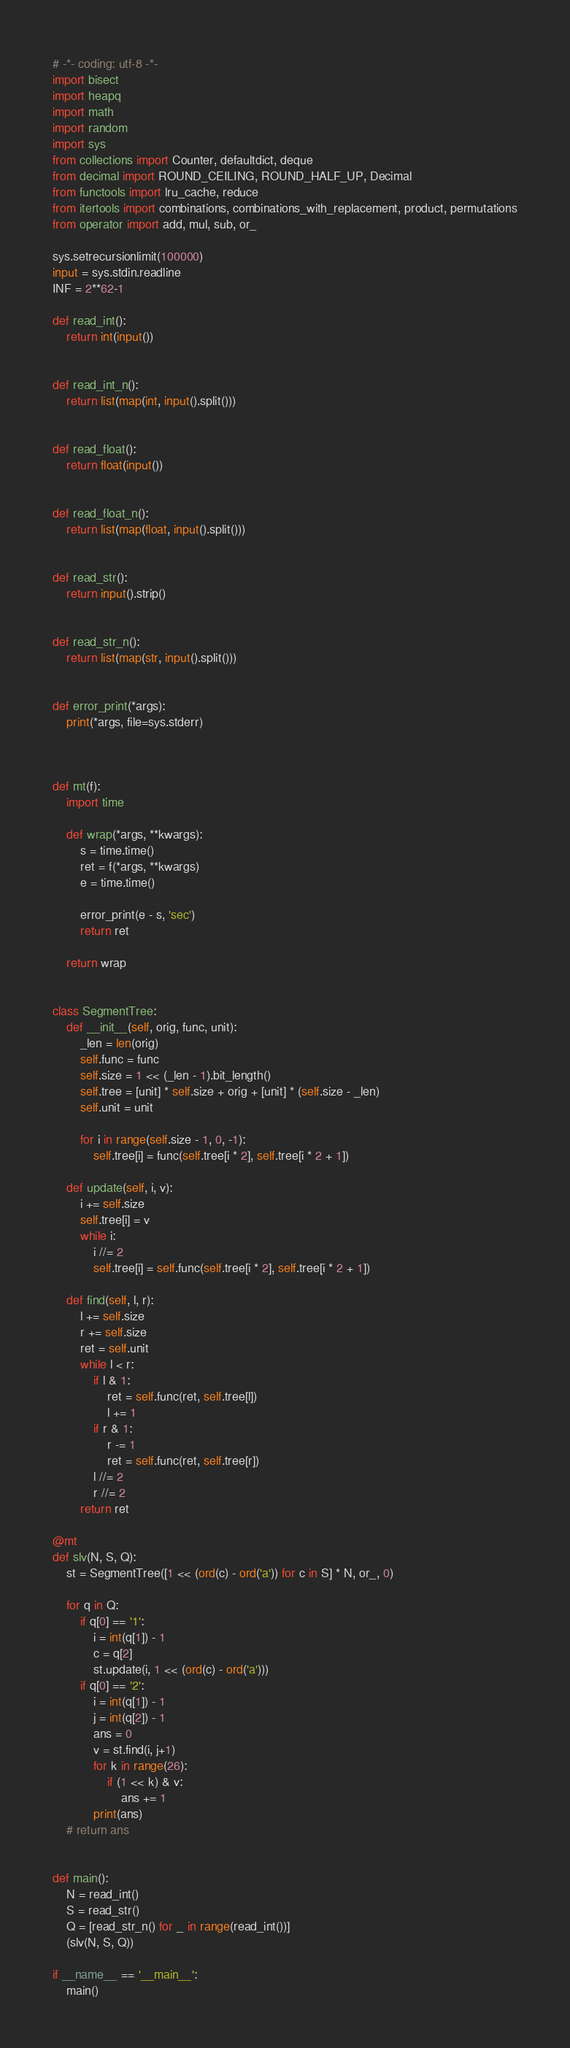<code> <loc_0><loc_0><loc_500><loc_500><_Python_># -*- coding: utf-8 -*-
import bisect
import heapq
import math
import random
import sys
from collections import Counter, defaultdict, deque
from decimal import ROUND_CEILING, ROUND_HALF_UP, Decimal
from functools import lru_cache, reduce
from itertools import combinations, combinations_with_replacement, product, permutations
from operator import add, mul, sub, or_

sys.setrecursionlimit(100000)
input = sys.stdin.readline
INF = 2**62-1

def read_int():
    return int(input())


def read_int_n():
    return list(map(int, input().split()))


def read_float():
    return float(input())


def read_float_n():
    return list(map(float, input().split()))


def read_str():
    return input().strip()


def read_str_n():
    return list(map(str, input().split()))


def error_print(*args):
    print(*args, file=sys.stderr)



def mt(f):
    import time

    def wrap(*args, **kwargs):
        s = time.time()
        ret = f(*args, **kwargs)
        e = time.time()

        error_print(e - s, 'sec')
        return ret

    return wrap


class SegmentTree:
	def __init__(self, orig, func, unit):
		_len = len(orig)
		self.func = func
		self.size = 1 << (_len - 1).bit_length()
		self.tree = [unit] * self.size + orig + [unit] * (self.size - _len)
		self.unit = unit

		for i in range(self.size - 1, 0, -1):
			self.tree[i] = func(self.tree[i * 2], self.tree[i * 2 + 1])

	def update(self, i, v):
		i += self.size
		self.tree[i] = v
		while i:
			i //= 2
			self.tree[i] = self.func(self.tree[i * 2], self.tree[i * 2 + 1])

	def find(self, l, r):
		l += self.size
		r += self.size
		ret = self.unit
		while l < r:
			if l & 1:
				ret = self.func(ret, self.tree[l])
				l += 1
			if r & 1:
				r -= 1
				ret = self.func(ret, self.tree[r])
			l //= 2
			r //= 2
		return ret

@mt
def slv(N, S, Q):
    st = SegmentTree([1 << (ord(c) - ord('a')) for c in S] * N, or_, 0)

    for q in Q:
        if q[0] == '1':
            i = int(q[1]) - 1
            c = q[2]
            st.update(i, 1 << (ord(c) - ord('a')))
        if q[0] == '2':
            i = int(q[1]) - 1
            j = int(q[2]) - 1
            ans = 0
            v = st.find(i, j+1)
            for k in range(26):
                if (1 << k) & v:
                    ans += 1
            print(ans)
    # return ans


def main():
    N = read_int()
    S = read_str()
    Q = [read_str_n() for _ in range(read_int())]
    (slv(N, S, Q))

if __name__ == '__main__':
    main()
</code> 